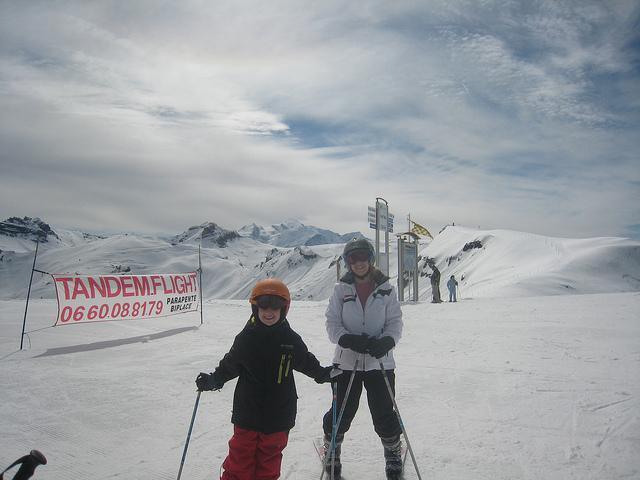What type of activity is this?
Make your selection from the four choices given to correctly answer the question.
Options: Winter, aquatic, summer, tropical. Winter. 